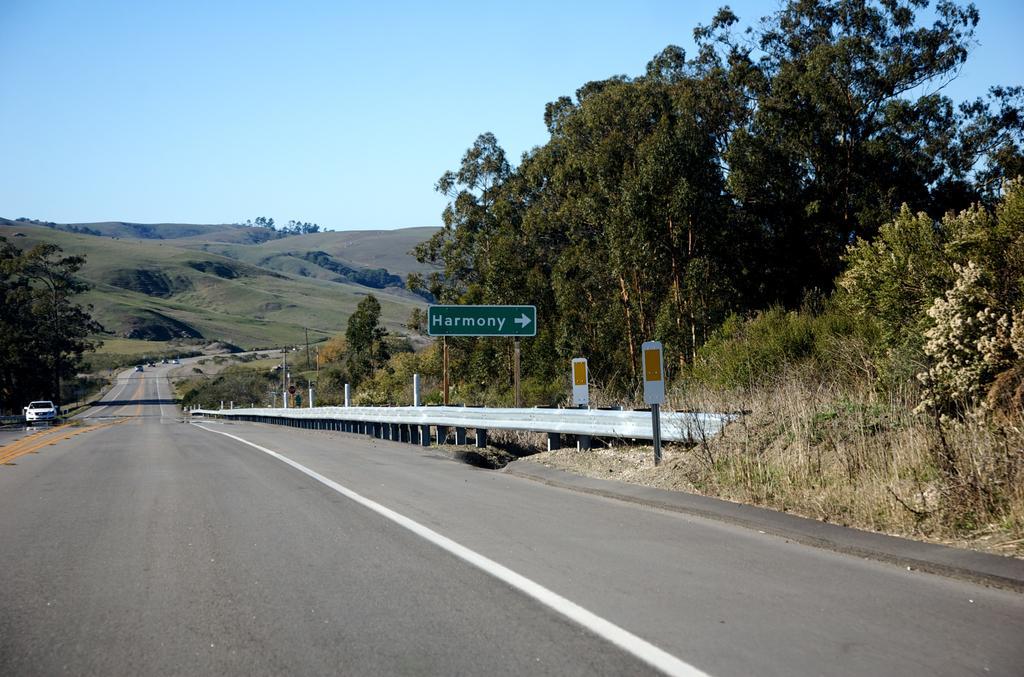Describe this image in one or two sentences. In this image in front there are vehicles on the road. On the right side of the image there are boards. In the background of the image there are trees, mountains and sky. 